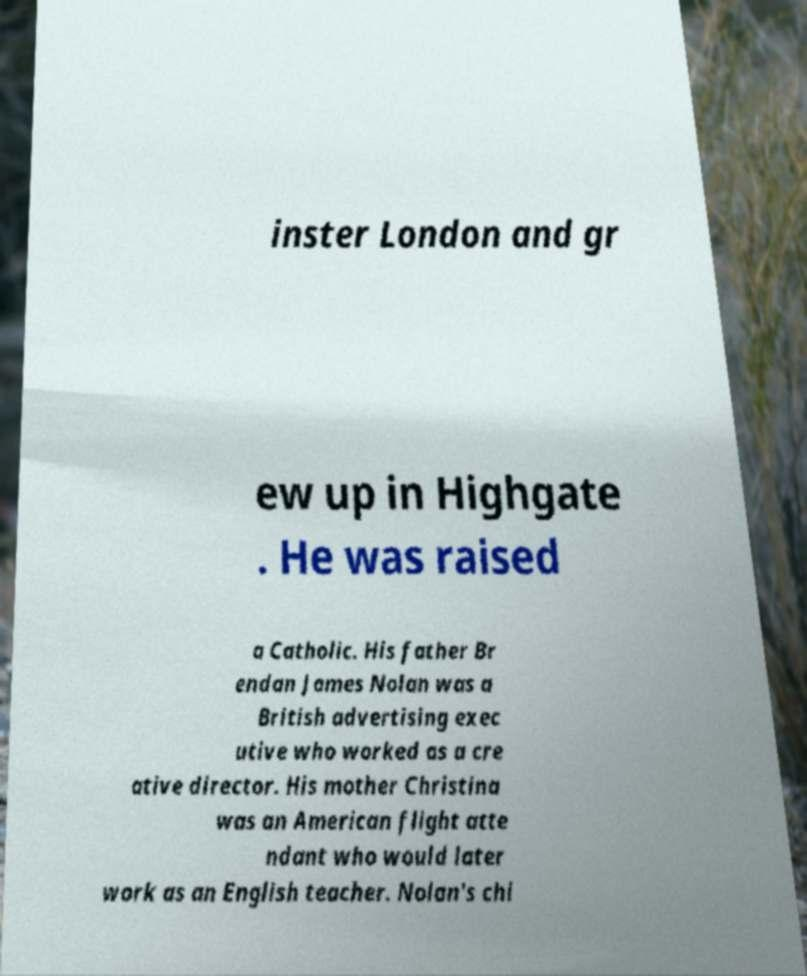For documentation purposes, I need the text within this image transcribed. Could you provide that? inster London and gr ew up in Highgate . He was raised a Catholic. His father Br endan James Nolan was a British advertising exec utive who worked as a cre ative director. His mother Christina was an American flight atte ndant who would later work as an English teacher. Nolan's chi 